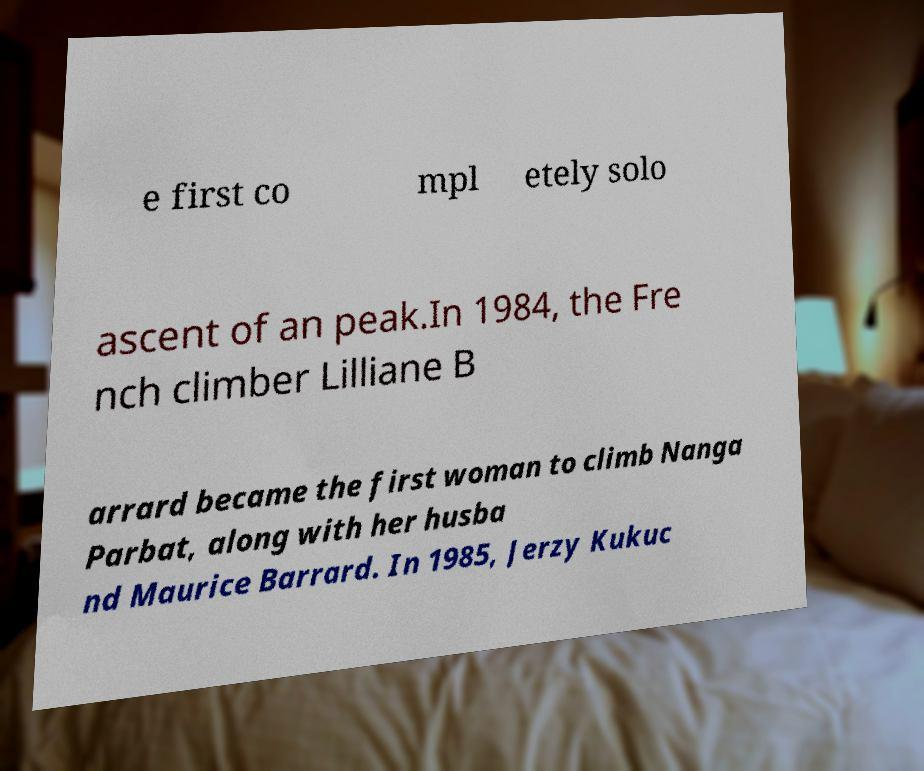Could you extract and type out the text from this image? e first co mpl etely solo ascent of an peak.In 1984, the Fre nch climber Lilliane B arrard became the first woman to climb Nanga Parbat, along with her husba nd Maurice Barrard. In 1985, Jerzy Kukuc 